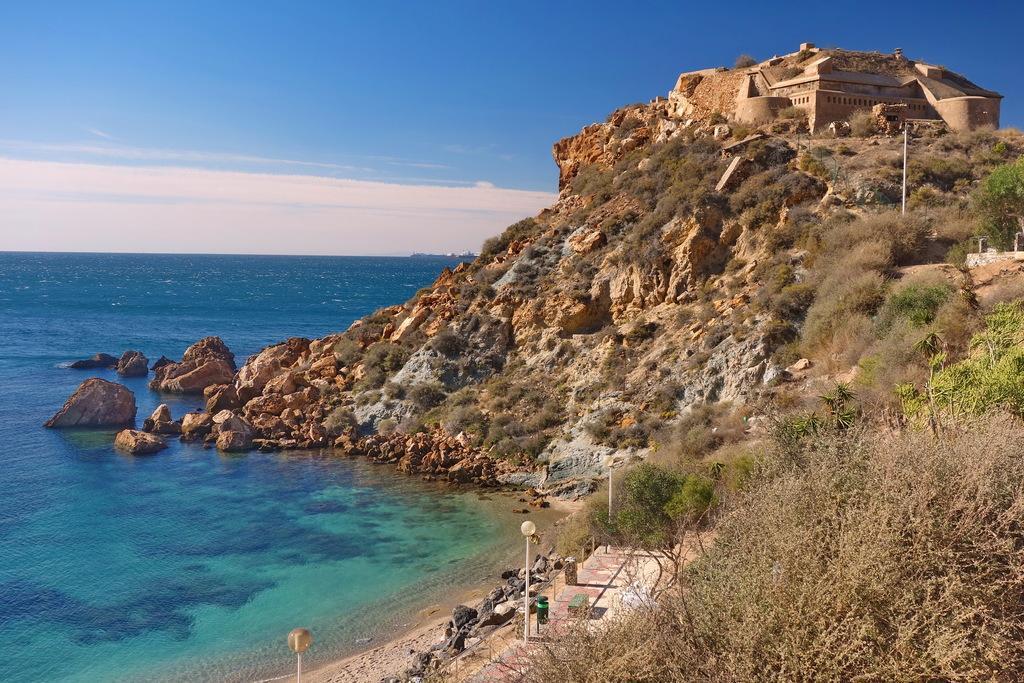Can you describe this image briefly? In this image we can see sky with clouds, sea, rocks, stones, street poles, street lights, trees and a building on the top of the hill. 